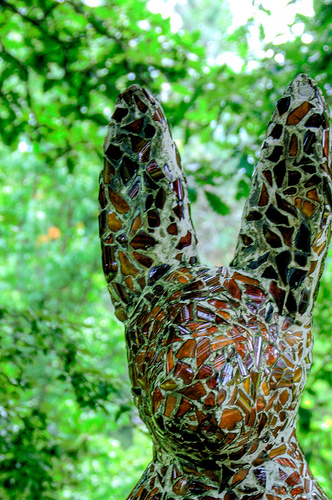<image>
Is the statue next to the plant? No. The statue is not positioned next to the plant. They are located in different areas of the scene. 